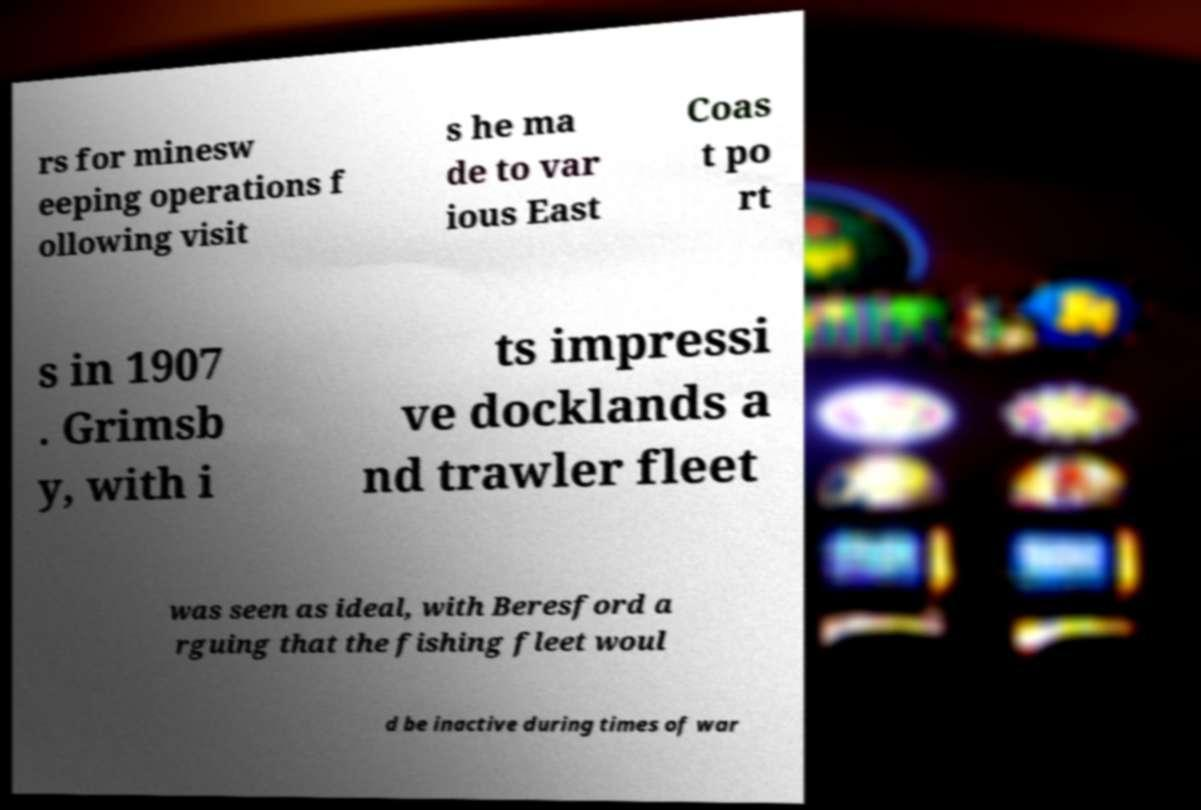Please read and relay the text visible in this image. What does it say? rs for minesw eeping operations f ollowing visit s he ma de to var ious East Coas t po rt s in 1907 . Grimsb y, with i ts impressi ve docklands a nd trawler fleet was seen as ideal, with Beresford a rguing that the fishing fleet woul d be inactive during times of war 